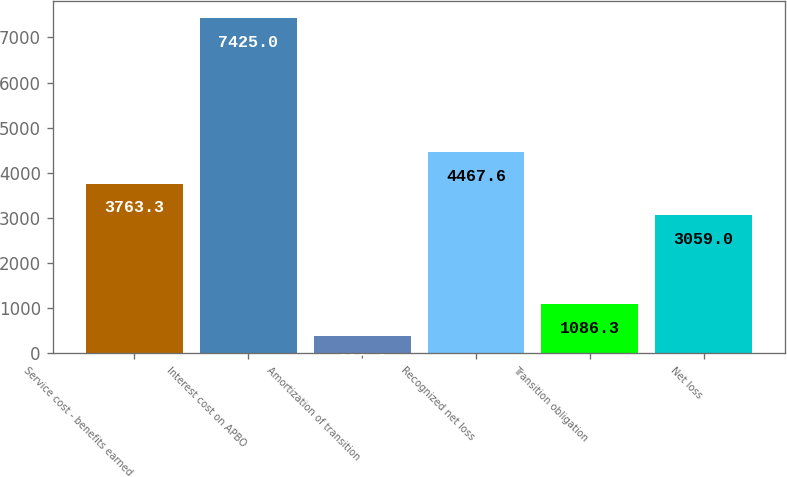Convert chart to OTSL. <chart><loc_0><loc_0><loc_500><loc_500><bar_chart><fcel>Service cost - benefits earned<fcel>Interest cost on APBO<fcel>Amortization of transition<fcel>Recognized net loss<fcel>Transition obligation<fcel>Net loss<nl><fcel>3763.3<fcel>7425<fcel>382<fcel>4467.6<fcel>1086.3<fcel>3059<nl></chart> 